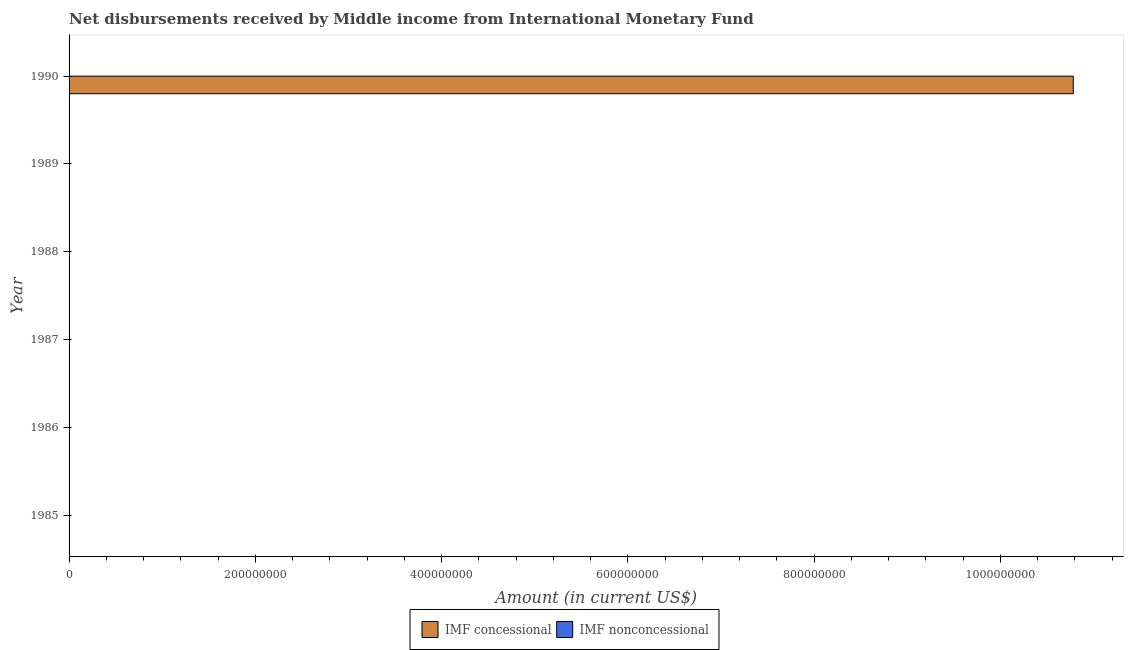How many different coloured bars are there?
Offer a terse response. 1. Are the number of bars per tick equal to the number of legend labels?
Keep it short and to the point. No. Are the number of bars on each tick of the Y-axis equal?
Ensure brevity in your answer.  No. In how many cases, is the number of bars for a given year not equal to the number of legend labels?
Your answer should be very brief. 6. What is the net concessional disbursements from imf in 1988?
Offer a terse response. 0. Across all years, what is the maximum net concessional disbursements from imf?
Your response must be concise. 1.08e+09. Across all years, what is the minimum net concessional disbursements from imf?
Offer a very short reply. 0. In which year was the net concessional disbursements from imf maximum?
Keep it short and to the point. 1990. What is the total net concessional disbursements from imf in the graph?
Ensure brevity in your answer.  1.08e+09. What is the average net concessional disbursements from imf per year?
Offer a very short reply. 1.80e+08. In how many years, is the net non concessional disbursements from imf greater than 280000000 US$?
Provide a succinct answer. 0. What is the difference between the highest and the lowest net concessional disbursements from imf?
Your answer should be very brief. 1.08e+09. In how many years, is the net non concessional disbursements from imf greater than the average net non concessional disbursements from imf taken over all years?
Your response must be concise. 0. Does the graph contain any zero values?
Your answer should be compact. Yes. Does the graph contain grids?
Your answer should be compact. No. How many legend labels are there?
Keep it short and to the point. 2. How are the legend labels stacked?
Give a very brief answer. Horizontal. What is the title of the graph?
Offer a terse response. Net disbursements received by Middle income from International Monetary Fund. Does "Manufacturing industries and construction" appear as one of the legend labels in the graph?
Your answer should be very brief. No. What is the label or title of the X-axis?
Make the answer very short. Amount (in current US$). What is the Amount (in current US$) of IMF nonconcessional in 1986?
Give a very brief answer. 0. What is the Amount (in current US$) of IMF concessional in 1987?
Offer a very short reply. 0. What is the Amount (in current US$) in IMF concessional in 1990?
Keep it short and to the point. 1.08e+09. Across all years, what is the maximum Amount (in current US$) of IMF concessional?
Provide a short and direct response. 1.08e+09. Across all years, what is the minimum Amount (in current US$) of IMF concessional?
Make the answer very short. 0. What is the total Amount (in current US$) of IMF concessional in the graph?
Your response must be concise. 1.08e+09. What is the total Amount (in current US$) of IMF nonconcessional in the graph?
Offer a terse response. 0. What is the average Amount (in current US$) of IMF concessional per year?
Provide a short and direct response. 1.80e+08. What is the difference between the highest and the lowest Amount (in current US$) in IMF concessional?
Provide a succinct answer. 1.08e+09. 